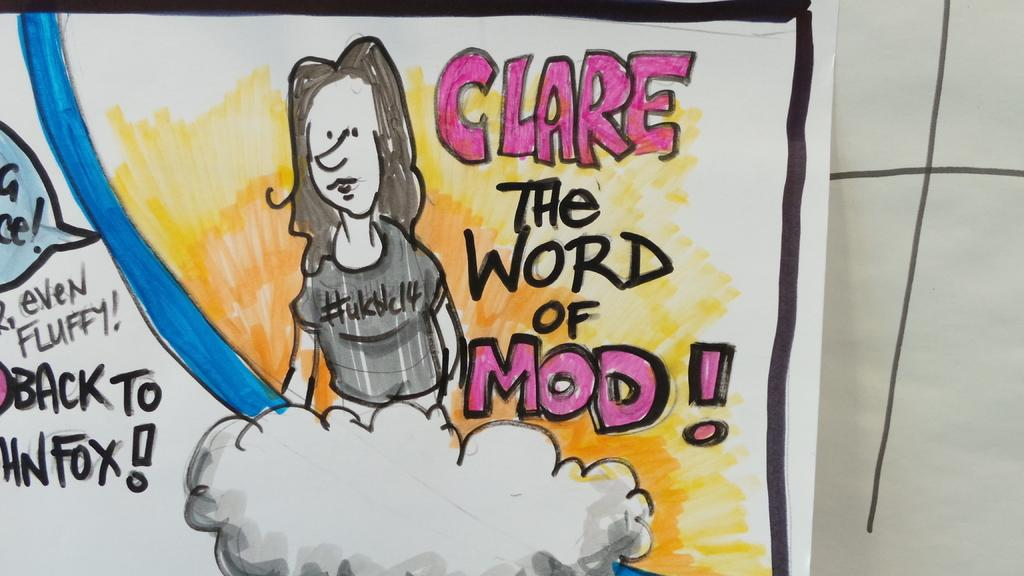What is the main subject in the center of the image? There is a paper in the center of the image. What can be seen on the paper? There are drawings and writing on the paper. Where is the plantation located in the image? There is no plantation present in the image; it features a paper with drawings and writing. What type of spoon is used to create the drawings on the paper? There is no spoon mentioned or visible in the image; the drawings were likely created using a pen, pencil, or other drawing tool. 